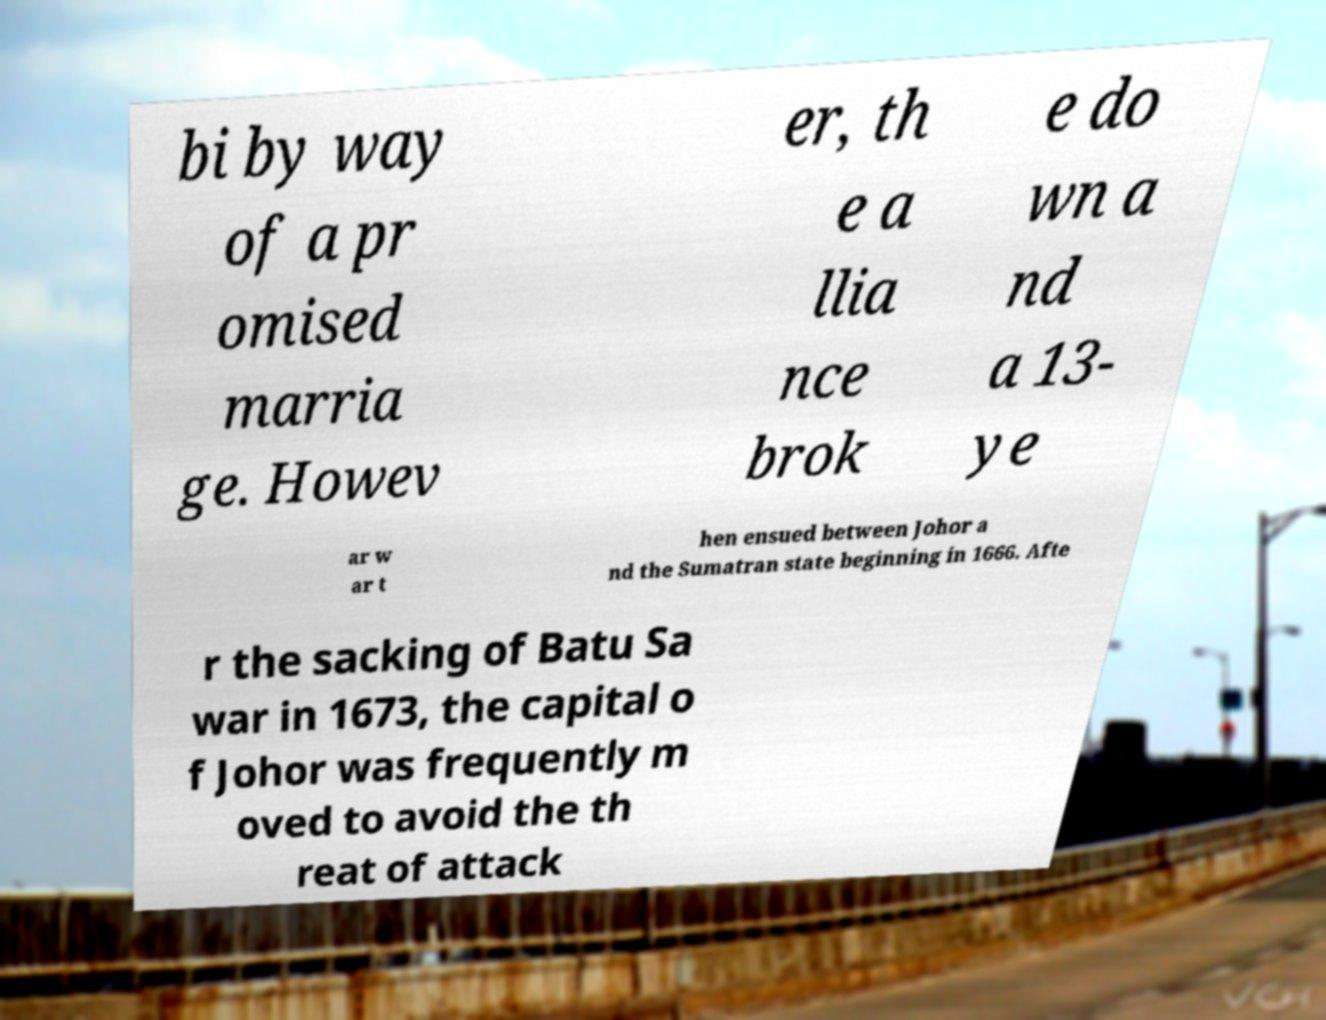Can you accurately transcribe the text from the provided image for me? bi by way of a pr omised marria ge. Howev er, th e a llia nce brok e do wn a nd a 13- ye ar w ar t hen ensued between Johor a nd the Sumatran state beginning in 1666. Afte r the sacking of Batu Sa war in 1673, the capital o f Johor was frequently m oved to avoid the th reat of attack 